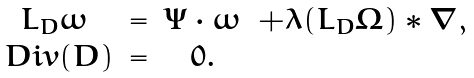Convert formula to latex. <formula><loc_0><loc_0><loc_500><loc_500>\begin{matrix} L _ { D } \omega & = & \Psi \cdot \omega & + \lambda ( L _ { D } \Omega ) * \nabla , \\ \ D i v ( D ) & = & 0 . & \end{matrix}</formula> 